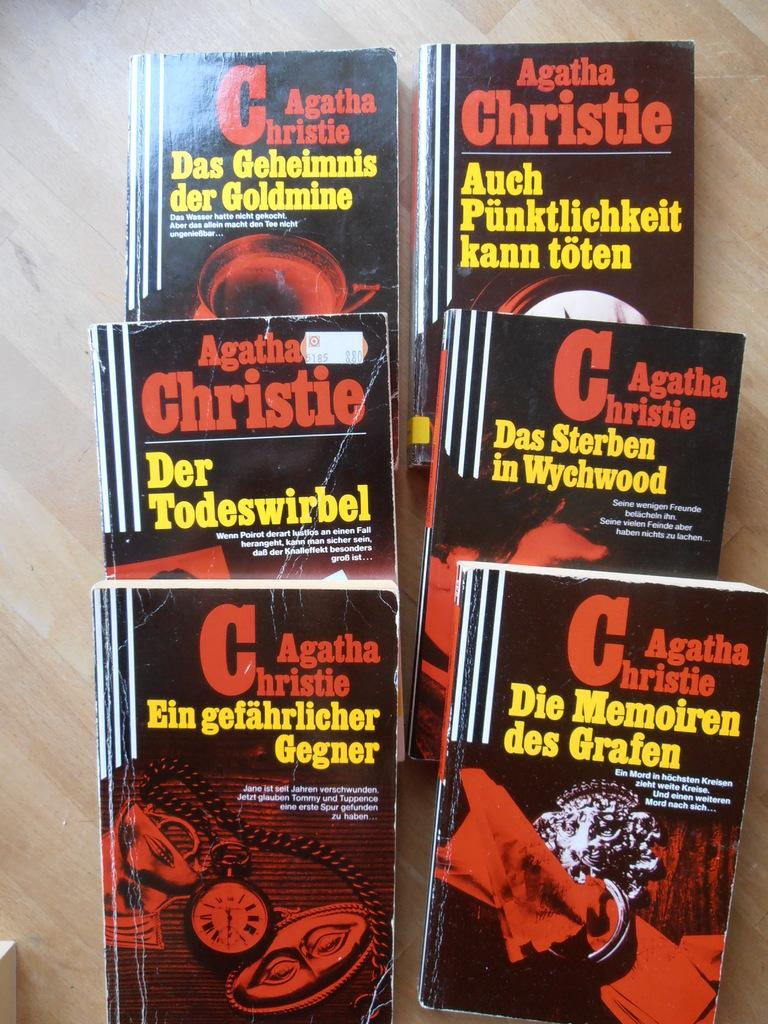<image>
Present a compact description of the photo's key features. books that are all by the author agatha christie 